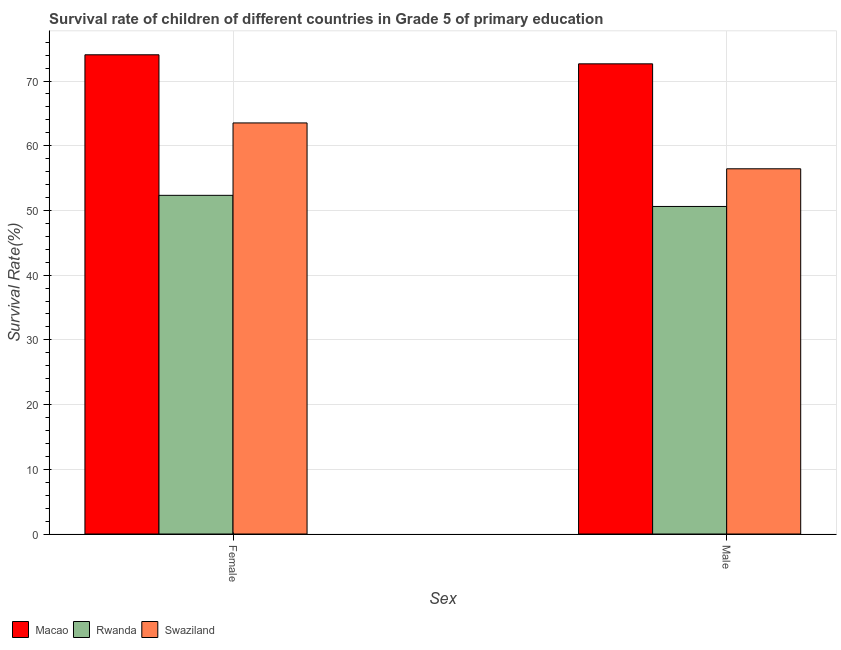How many different coloured bars are there?
Your answer should be very brief. 3. How many groups of bars are there?
Offer a terse response. 2. Are the number of bars on each tick of the X-axis equal?
Provide a succinct answer. Yes. What is the label of the 1st group of bars from the left?
Your answer should be compact. Female. What is the survival rate of male students in primary education in Macao?
Offer a very short reply. 72.66. Across all countries, what is the maximum survival rate of female students in primary education?
Your answer should be very brief. 74.06. Across all countries, what is the minimum survival rate of female students in primary education?
Give a very brief answer. 52.34. In which country was the survival rate of female students in primary education maximum?
Ensure brevity in your answer.  Macao. In which country was the survival rate of male students in primary education minimum?
Keep it short and to the point. Rwanda. What is the total survival rate of female students in primary education in the graph?
Offer a very short reply. 189.93. What is the difference between the survival rate of male students in primary education in Swaziland and that in Macao?
Your answer should be very brief. -16.22. What is the difference between the survival rate of male students in primary education in Macao and the survival rate of female students in primary education in Swaziland?
Ensure brevity in your answer.  9.13. What is the average survival rate of male students in primary education per country?
Provide a succinct answer. 59.91. What is the difference between the survival rate of male students in primary education and survival rate of female students in primary education in Rwanda?
Ensure brevity in your answer.  -1.72. What is the ratio of the survival rate of female students in primary education in Swaziland to that in Rwanda?
Ensure brevity in your answer.  1.21. Is the survival rate of female students in primary education in Swaziland less than that in Rwanda?
Provide a succinct answer. No. What does the 3rd bar from the left in Female represents?
Give a very brief answer. Swaziland. What does the 2nd bar from the right in Female represents?
Give a very brief answer. Rwanda. How many bars are there?
Give a very brief answer. 6. Are all the bars in the graph horizontal?
Provide a short and direct response. No. Are the values on the major ticks of Y-axis written in scientific E-notation?
Your response must be concise. No. Does the graph contain any zero values?
Your response must be concise. No. Where does the legend appear in the graph?
Keep it short and to the point. Bottom left. How many legend labels are there?
Your answer should be compact. 3. What is the title of the graph?
Make the answer very short. Survival rate of children of different countries in Grade 5 of primary education. Does "Low & middle income" appear as one of the legend labels in the graph?
Keep it short and to the point. No. What is the label or title of the X-axis?
Give a very brief answer. Sex. What is the label or title of the Y-axis?
Ensure brevity in your answer.  Survival Rate(%). What is the Survival Rate(%) in Macao in Female?
Your answer should be compact. 74.06. What is the Survival Rate(%) in Rwanda in Female?
Offer a very short reply. 52.34. What is the Survival Rate(%) in Swaziland in Female?
Give a very brief answer. 63.53. What is the Survival Rate(%) of Macao in Male?
Provide a succinct answer. 72.66. What is the Survival Rate(%) of Rwanda in Male?
Your answer should be very brief. 50.62. What is the Survival Rate(%) of Swaziland in Male?
Your answer should be very brief. 56.44. Across all Sex, what is the maximum Survival Rate(%) in Macao?
Keep it short and to the point. 74.06. Across all Sex, what is the maximum Survival Rate(%) in Rwanda?
Offer a terse response. 52.34. Across all Sex, what is the maximum Survival Rate(%) in Swaziland?
Offer a very short reply. 63.53. Across all Sex, what is the minimum Survival Rate(%) in Macao?
Your answer should be very brief. 72.66. Across all Sex, what is the minimum Survival Rate(%) of Rwanda?
Keep it short and to the point. 50.62. Across all Sex, what is the minimum Survival Rate(%) in Swaziland?
Provide a succinct answer. 56.44. What is the total Survival Rate(%) in Macao in the graph?
Your response must be concise. 146.72. What is the total Survival Rate(%) of Rwanda in the graph?
Give a very brief answer. 102.96. What is the total Survival Rate(%) of Swaziland in the graph?
Your answer should be compact. 119.97. What is the difference between the Survival Rate(%) of Macao in Female and that in Male?
Provide a succinct answer. 1.4. What is the difference between the Survival Rate(%) of Rwanda in Female and that in Male?
Provide a short and direct response. 1.72. What is the difference between the Survival Rate(%) of Swaziland in Female and that in Male?
Offer a terse response. 7.09. What is the difference between the Survival Rate(%) of Macao in Female and the Survival Rate(%) of Rwanda in Male?
Offer a very short reply. 23.44. What is the difference between the Survival Rate(%) of Macao in Female and the Survival Rate(%) of Swaziland in Male?
Keep it short and to the point. 17.62. What is the difference between the Survival Rate(%) of Rwanda in Female and the Survival Rate(%) of Swaziland in Male?
Offer a very short reply. -4.1. What is the average Survival Rate(%) in Macao per Sex?
Make the answer very short. 73.36. What is the average Survival Rate(%) of Rwanda per Sex?
Make the answer very short. 51.48. What is the average Survival Rate(%) in Swaziland per Sex?
Keep it short and to the point. 59.98. What is the difference between the Survival Rate(%) in Macao and Survival Rate(%) in Rwanda in Female?
Provide a short and direct response. 21.72. What is the difference between the Survival Rate(%) in Macao and Survival Rate(%) in Swaziland in Female?
Ensure brevity in your answer.  10.53. What is the difference between the Survival Rate(%) in Rwanda and Survival Rate(%) in Swaziland in Female?
Ensure brevity in your answer.  -11.19. What is the difference between the Survival Rate(%) in Macao and Survival Rate(%) in Rwanda in Male?
Your answer should be compact. 22.04. What is the difference between the Survival Rate(%) in Macao and Survival Rate(%) in Swaziland in Male?
Keep it short and to the point. 16.22. What is the difference between the Survival Rate(%) in Rwanda and Survival Rate(%) in Swaziland in Male?
Keep it short and to the point. -5.82. What is the ratio of the Survival Rate(%) in Macao in Female to that in Male?
Give a very brief answer. 1.02. What is the ratio of the Survival Rate(%) in Rwanda in Female to that in Male?
Your answer should be compact. 1.03. What is the ratio of the Survival Rate(%) in Swaziland in Female to that in Male?
Your response must be concise. 1.13. What is the difference between the highest and the second highest Survival Rate(%) in Macao?
Give a very brief answer. 1.4. What is the difference between the highest and the second highest Survival Rate(%) in Rwanda?
Give a very brief answer. 1.72. What is the difference between the highest and the second highest Survival Rate(%) of Swaziland?
Your answer should be very brief. 7.09. What is the difference between the highest and the lowest Survival Rate(%) of Macao?
Give a very brief answer. 1.4. What is the difference between the highest and the lowest Survival Rate(%) of Rwanda?
Give a very brief answer. 1.72. What is the difference between the highest and the lowest Survival Rate(%) in Swaziland?
Keep it short and to the point. 7.09. 